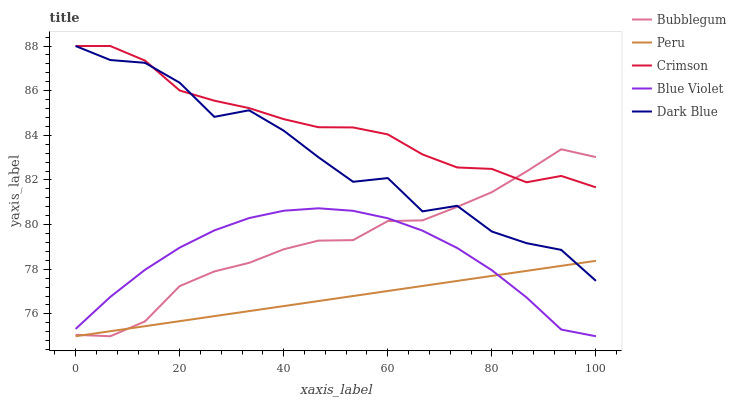Does Peru have the minimum area under the curve?
Answer yes or no. Yes. Does Crimson have the maximum area under the curve?
Answer yes or no. Yes. Does Dark Blue have the minimum area under the curve?
Answer yes or no. No. Does Dark Blue have the maximum area under the curve?
Answer yes or no. No. Is Peru the smoothest?
Answer yes or no. Yes. Is Dark Blue the roughest?
Answer yes or no. Yes. Is Blue Violet the smoothest?
Answer yes or no. No. Is Blue Violet the roughest?
Answer yes or no. No. Does Blue Violet have the lowest value?
Answer yes or no. Yes. Does Dark Blue have the lowest value?
Answer yes or no. No. Does Dark Blue have the highest value?
Answer yes or no. Yes. Does Blue Violet have the highest value?
Answer yes or no. No. Is Blue Violet less than Crimson?
Answer yes or no. Yes. Is Crimson greater than Blue Violet?
Answer yes or no. Yes. Does Dark Blue intersect Bubblegum?
Answer yes or no. Yes. Is Dark Blue less than Bubblegum?
Answer yes or no. No. Is Dark Blue greater than Bubblegum?
Answer yes or no. No. Does Blue Violet intersect Crimson?
Answer yes or no. No. 